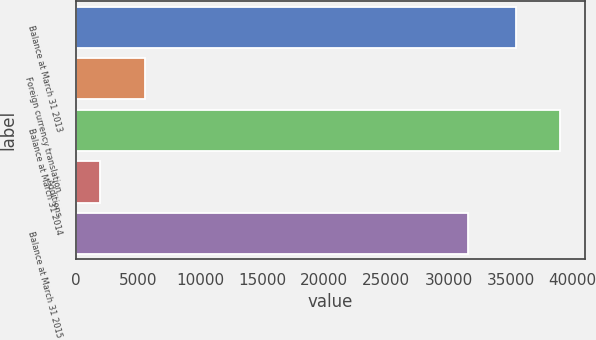<chart> <loc_0><loc_0><loc_500><loc_500><bar_chart><fcel>Balance at March 31 2013<fcel>Foreign currency translation<fcel>Balance at March 31 2014<fcel>Additions<fcel>Balance at March 31 2015<nl><fcel>35410<fcel>5566.6<fcel>39012.6<fcel>1964<fcel>31534<nl></chart> 